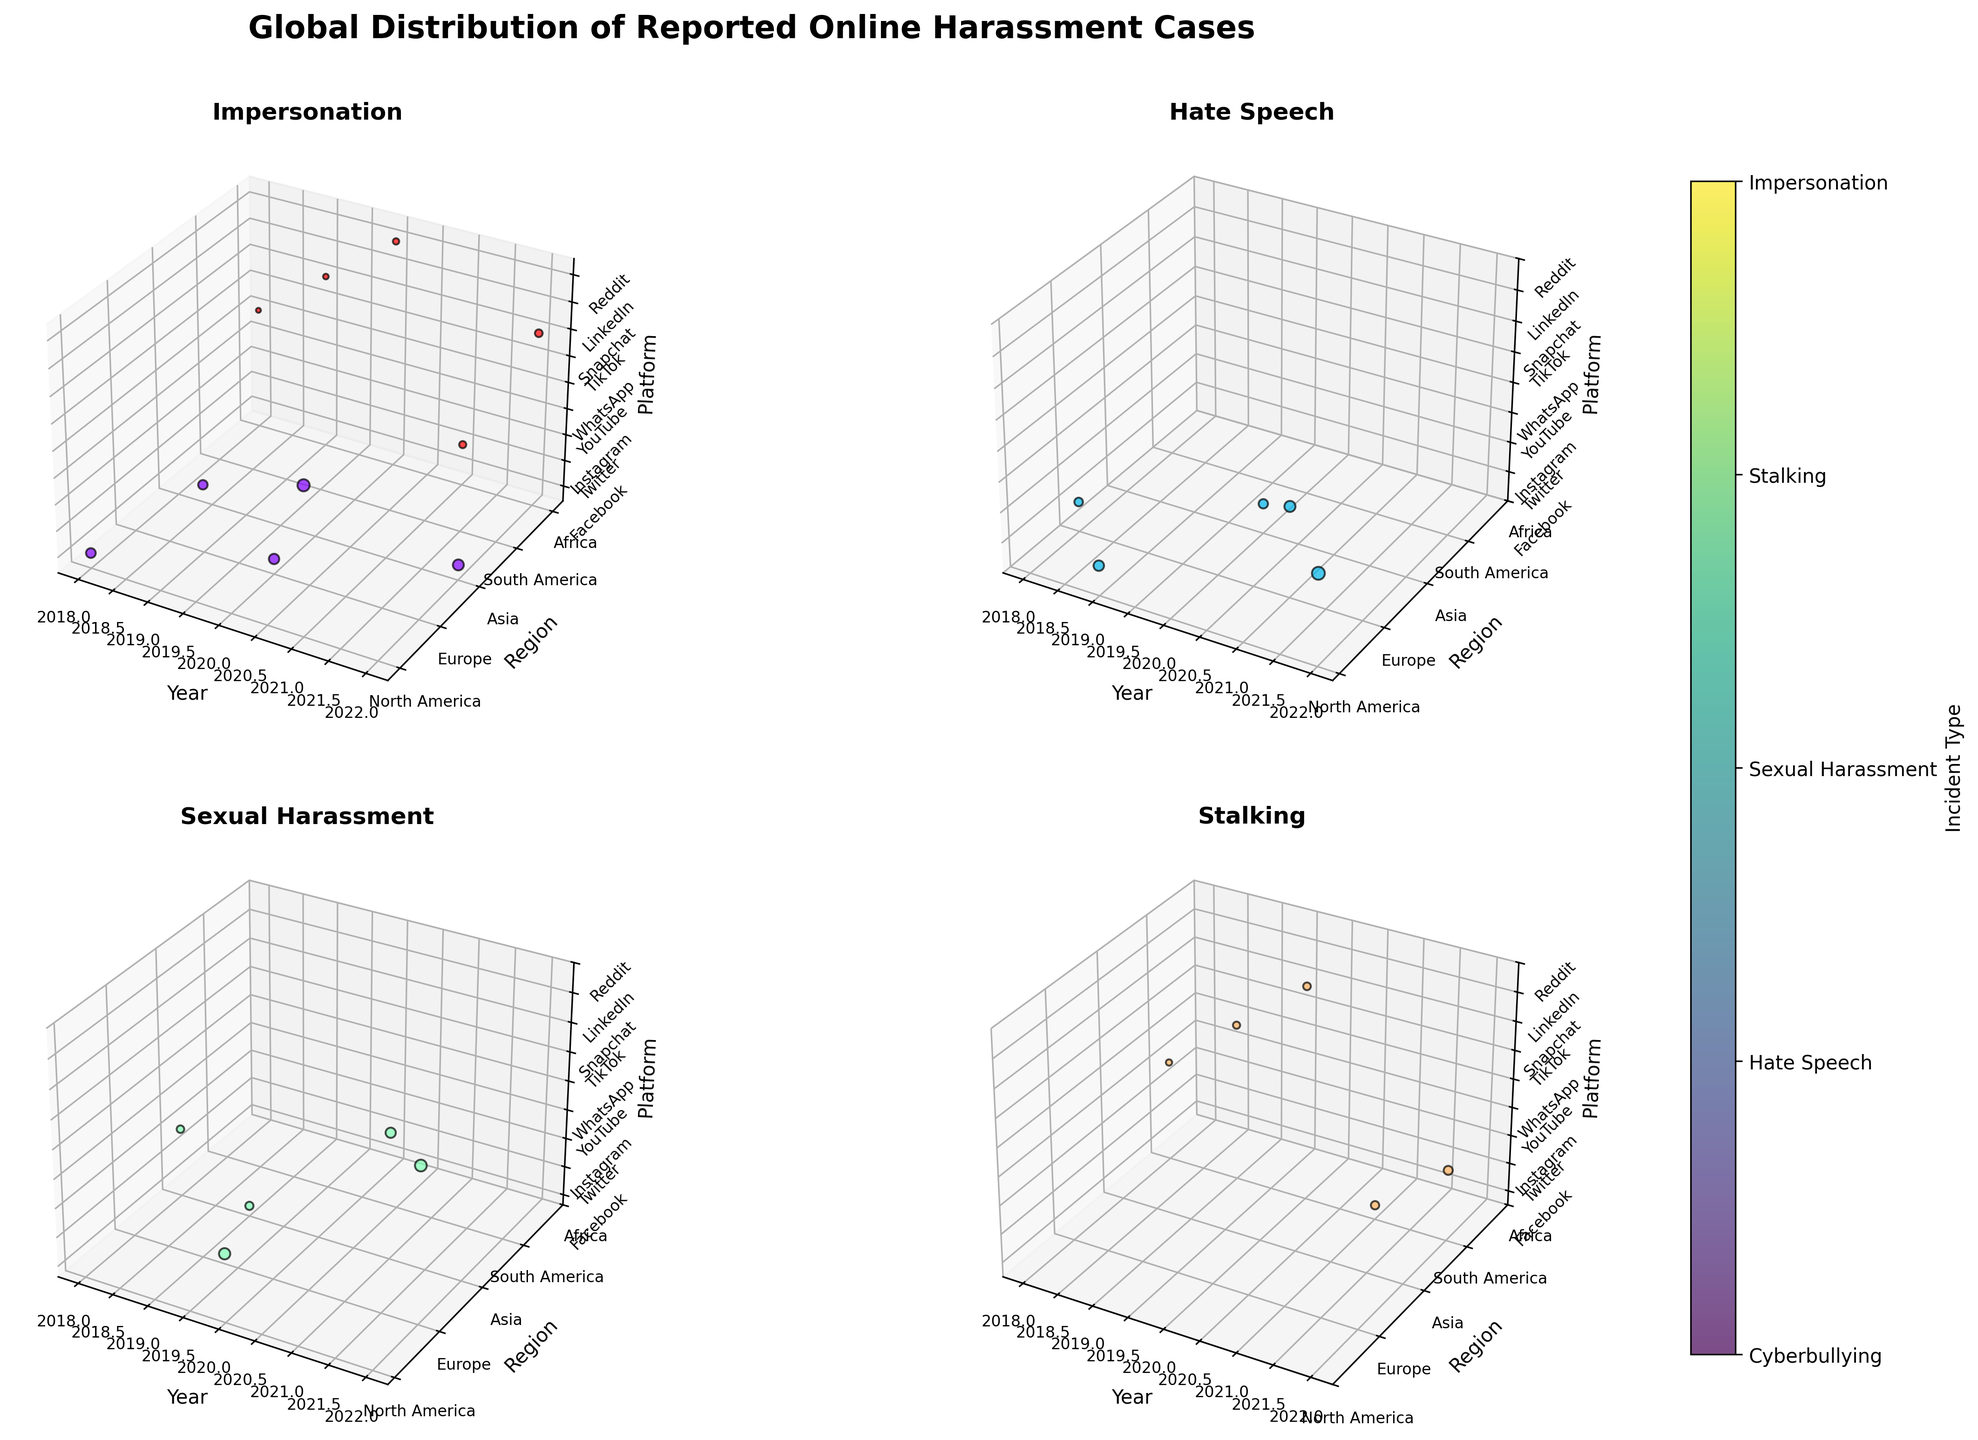What is the title of the figure? The title is usually displayed at the top of the figure. In this case, it is specified in the code as 'Global Distribution of Reported Online Harassment Cases'.
Answer: Global Distribution of Reported Online Harassment Cases What regions are represented in the plots? By looking at the y-axis tick labels on the subplots, which represent the regions as mapped in the 'Region' column of the data, we can identify the regions. There should be five unique regions represented.
Answer: North America, Europe, Asia, South America, Africa Which incident type is plotted in the first subplot? In the code, the first subplot corresponds to the first incident type listed in the data. The title of each subplot is set to the respective incident type.
Answer: Cyberbullying How did the number of 'Hate Speech' reported cases change in North America from 2018 to 2022? Examine the plot for 'Hate Speech'. Locate the data points corresponding to North America for 2018 and 2022. Compare the z-coordinates which represent the reported cases.
Answer: Increased (1250 to 1450 to 1150 to 1950 to 2210) Which platform had the highest number of reported 'Sexual Harassment' cases in 2020? In the 'Sexual Harassment' subplot, find the data points for the year 2020. Compare the z-coordinates (representing platforms) to find which one has the highest value.
Answer: Instagram Which subplot shows the largest spread in reported cases? Compare the subplots visually and determine which one has the data points most spread apart along the z-axis (representing the reported cases).
Answer: Sexual Harassment What trend do you observe for the 'Cyberbullying' incident type over the years? Check the 'Cyberbullying' subplot. Observe the trend of the data points along the x-axis (years) and how the reported cases (represented by size) change.
Answer: Increasing trend How many different platforms are displayed in the third subplot? The third subplot might correspond to a particular incident type. Count the unique platforms (z-axis) for that subplot.
Answer: 5 platforms Comparing 'Impersonation' and 'Stalking', which incident type had higher reported cases in Africa in 2021? Look at the subplots for 'Impersonation' and 'Stalking'. Check the reported cases (z-coordinates) for Africa in 2021. Compare the values.
Answer: Stalking (670 vs. 920) What platform was the primary medium for reported cases of 'Hate Speech' in Europe in 2021? In the 'Hate Speech' subplot, find the data point for Europe in 2021. Check the z-coordinate to identify the platform.
Answer: YouTube 